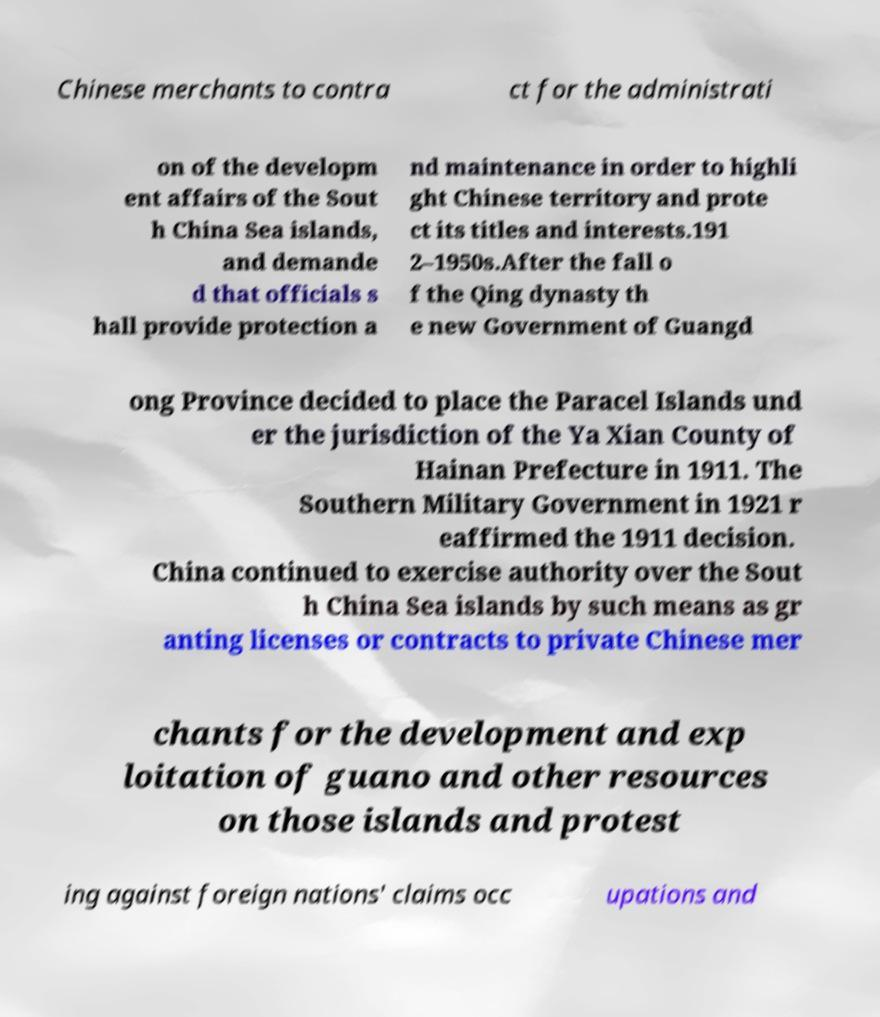Could you extract and type out the text from this image? Chinese merchants to contra ct for the administrati on of the developm ent affairs of the Sout h China Sea islands, and demande d that officials s hall provide protection a nd maintenance in order to highli ght Chinese territory and prote ct its titles and interests.191 2–1950s.After the fall o f the Qing dynasty th e new Government of Guangd ong Province decided to place the Paracel Islands und er the jurisdiction of the Ya Xian County of Hainan Prefecture in 1911. The Southern Military Government in 1921 r eaffirmed the 1911 decision. China continued to exercise authority over the Sout h China Sea islands by such means as gr anting licenses or contracts to private Chinese mer chants for the development and exp loitation of guano and other resources on those islands and protest ing against foreign nations' claims occ upations and 